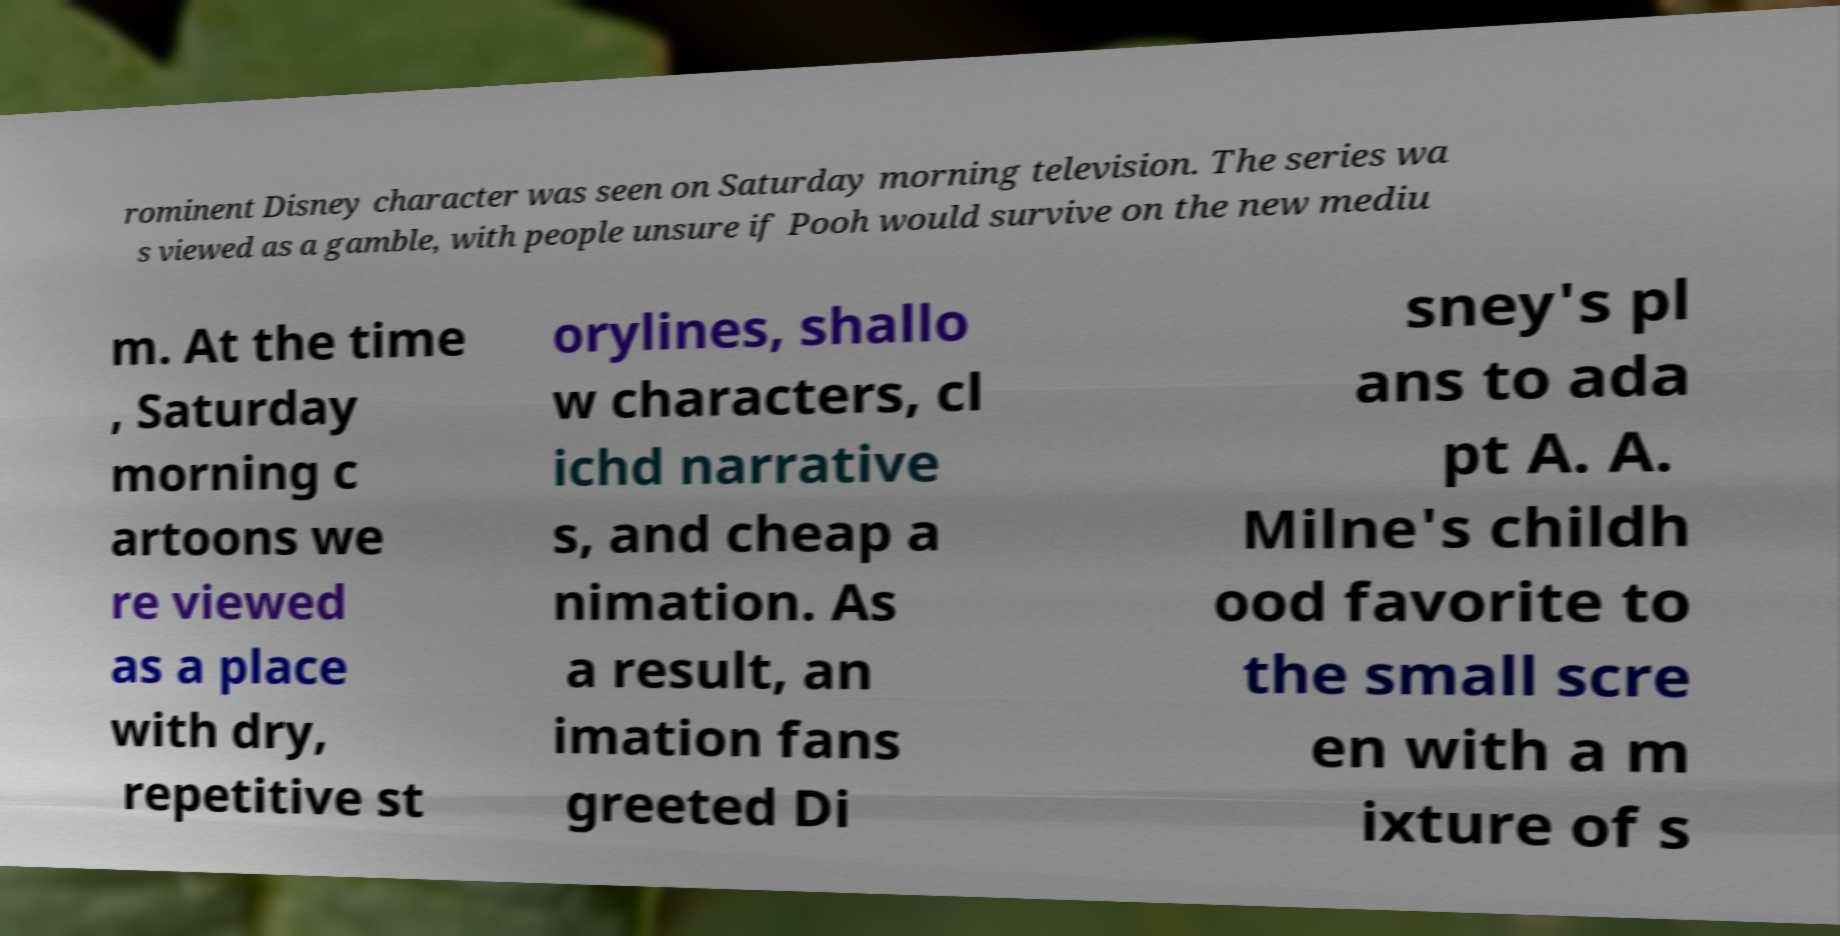Could you extract and type out the text from this image? rominent Disney character was seen on Saturday morning television. The series wa s viewed as a gamble, with people unsure if Pooh would survive on the new mediu m. At the time , Saturday morning c artoons we re viewed as a place with dry, repetitive st orylines, shallo w characters, cl ichd narrative s, and cheap a nimation. As a result, an imation fans greeted Di sney's pl ans to ada pt A. A. Milne's childh ood favorite to the small scre en with a m ixture of s 